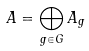Convert formula to latex. <formula><loc_0><loc_0><loc_500><loc_500>A = \bigoplus _ { g \in G } A _ { g }</formula> 